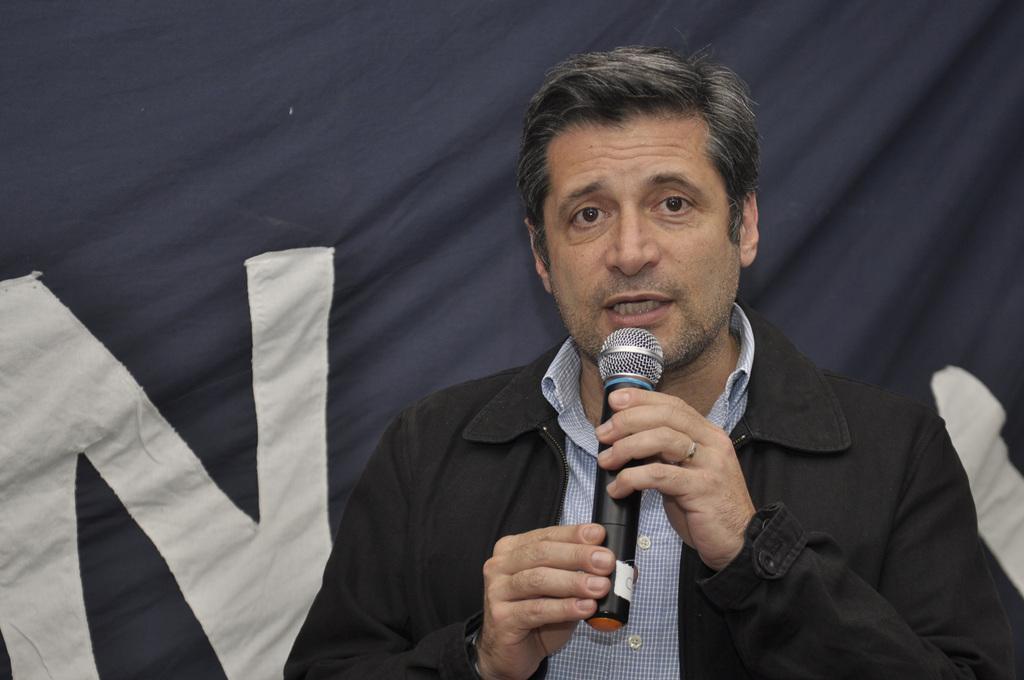Describe this image in one or two sentences. This picture shows a man speaking with the help of a microphone 